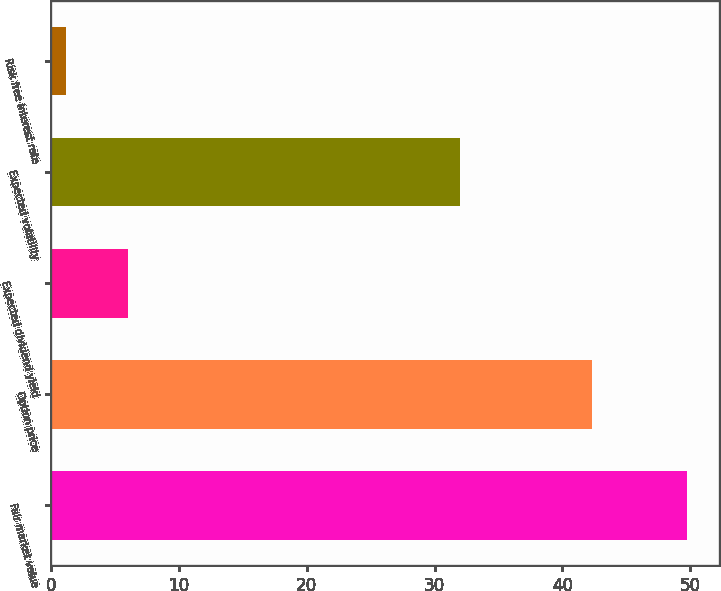Convert chart. <chart><loc_0><loc_0><loc_500><loc_500><bar_chart><fcel>Fair market value<fcel>Option price<fcel>Expected dividend yield<fcel>Expected volatility<fcel>Risk free interest rate<nl><fcel>49.76<fcel>42.29<fcel>6.05<fcel>32<fcel>1.19<nl></chart> 